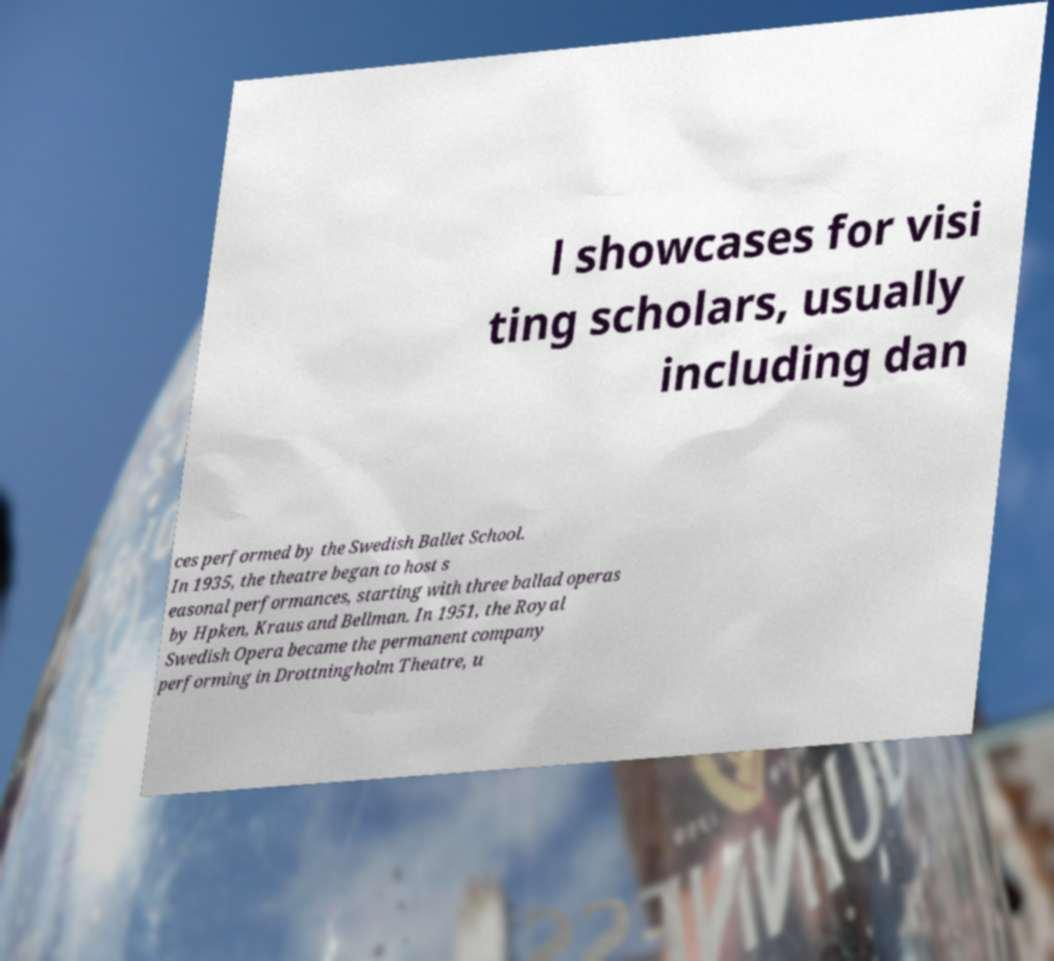Could you extract and type out the text from this image? l showcases for visi ting scholars, usually including dan ces performed by the Swedish Ballet School. In 1935, the theatre began to host s easonal performances, starting with three ballad operas by Hpken, Kraus and Bellman. In 1951, the Royal Swedish Opera became the permanent company performing in Drottningholm Theatre, u 